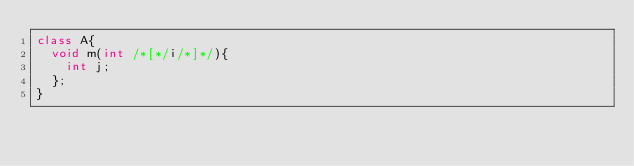<code> <loc_0><loc_0><loc_500><loc_500><_Java_>class A{
	void m(int /*[*/i/*]*/){
		int j;
	};
}</code> 